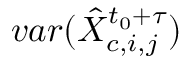<formula> <loc_0><loc_0><loc_500><loc_500>v a r ( \hat { X } _ { c , i , j } ^ { t _ { 0 } + \tau } )</formula> 